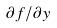Convert formula to latex. <formula><loc_0><loc_0><loc_500><loc_500>\partial f / \partial y</formula> 